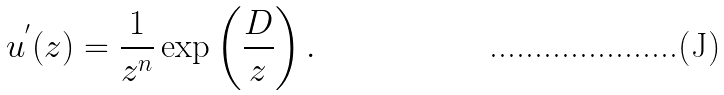<formula> <loc_0><loc_0><loc_500><loc_500>u ^ { ^ { \prime } } ( z ) = \frac { 1 } { z ^ { n } } \exp \left ( \frac { D } { z } \right ) .</formula> 